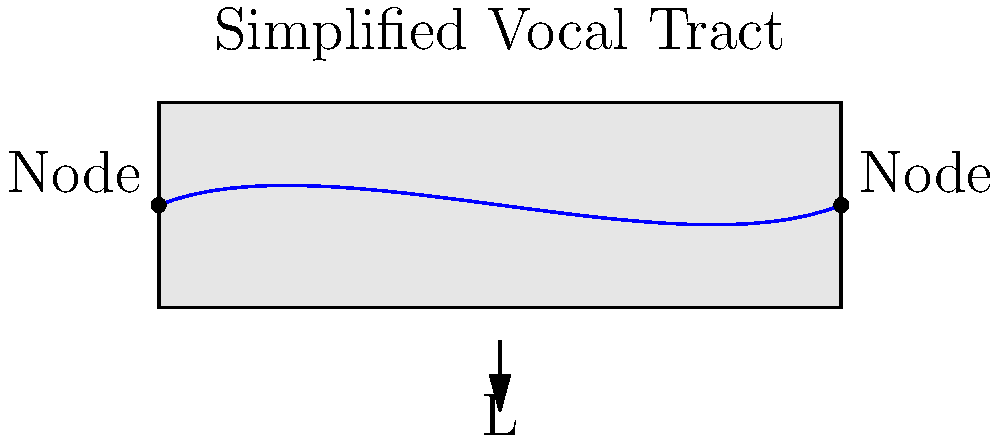A soprano is practicing her vocal techniques and wants to understand the physics behind her voice production. She models her vocal tract as a cylindrical tube open at both ends, with a length of 17.5 cm. Assuming the speed of sound in air is 343 m/s, what is the fundamental frequency (in Hz) of this simplified vocal tract model? To solve this problem, we'll follow these steps:

1) The fundamental frequency of a tube open at both ends is given by the formula:

   $$f = \frac{v}{2L}$$

   Where:
   $f$ is the fundamental frequency
   $v$ is the speed of sound
   $L$ is the length of the tube

2) We're given:
   $v = 343$ m/s
   $L = 17.5$ cm = 0.175 m

3) Let's substitute these values into our equation:

   $$f = \frac{343 \text{ m/s}}{2(0.175 \text{ m})}$$

4) Now we can calculate:

   $$f = \frac{343}{0.35} = 980 \text{ Hz}$$

5) Rounding to the nearest whole number:

   $$f \approx 980 \text{ Hz}$$

This frequency corresponds to approximately B5 on the musical scale, which is within the typical soprano range.
Answer: 980 Hz 